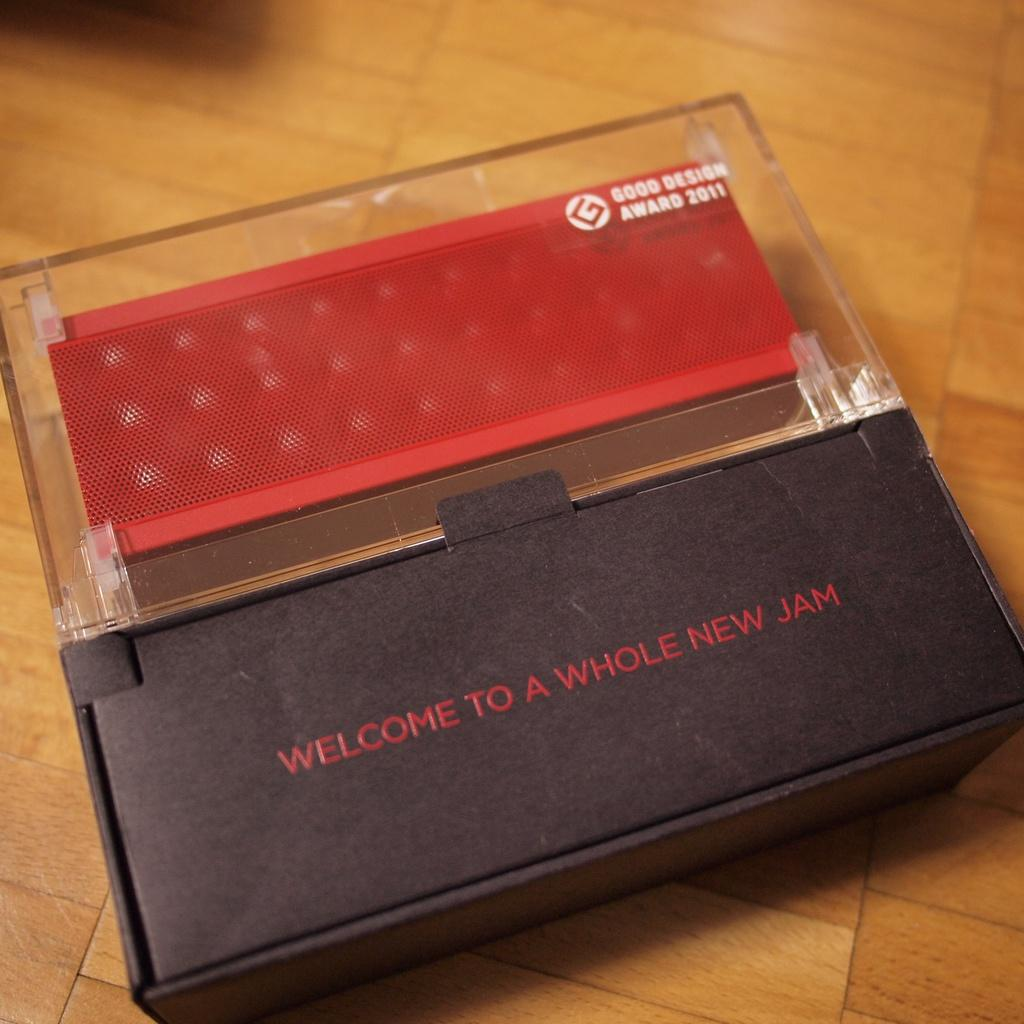<image>
Describe the image concisely. Wireless speaker that received the Good Design award in 2011. 